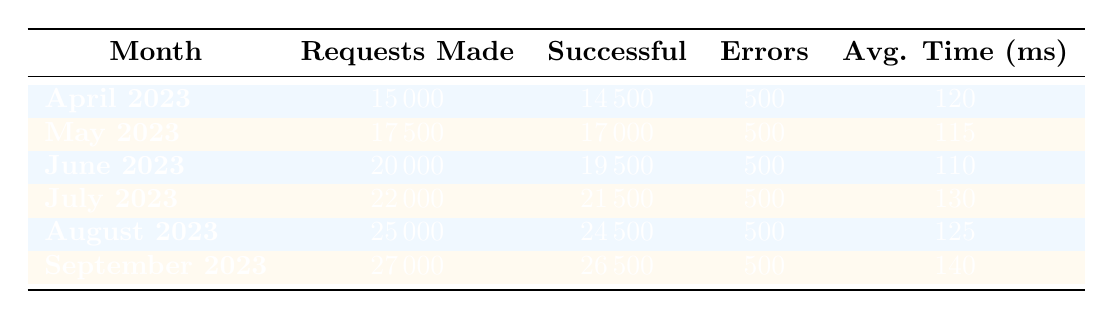What is the average response time in August 2023? The table shows that the average response time for August 2023 is listed directly under the "Avg. Time (ms)" column. It states 125 milliseconds.
Answer: 125 How many total requests were made in June and July 2023? To find the total requests for June and July, we add the "Requests Made" values for these months: 20000 (June) + 22000 (July) = 42000.
Answer: 42000 What is the trend of successful responses from April to September 2023? By examining the "Successful" column in the table, we can see that successful responses increased from 14500 in April to 26500 in September, indicating a consistent upward trend over the months.
Answer: Yes, there is an upward trend Did the number of error responses change from April to September 2023? The "Errors" column for each month consistently shows 500 error responses, meaning the number of error responses did not change over these months.
Answer: No, it did not change What was the month with the highest number of requests made? By checking the "Requests Made" column, September 2023 has the highest value at 27000 requests, which is greater than all previous months.
Answer: September 2023 What is the average number of successful responses across all months? To calculate the average successful responses, we sum all the successful responses: 14500 + 17000 + 19500 + 21500 + 24500 + 26500 = 129500. There are 6 months, so the average is 129500 / 6 = 21583.33, which can be rounded to 21583.
Answer: Approximately 21583 How did the average response time change from April to September 2023? The average response times are 120 ms (April), 115 ms (May), 110 ms (June), 130 ms (July), 125 ms (August), and 140 ms (September). From the data, we see it decreased initially, then increased again by September, showing fluctuation.
Answer: Fluctuated In which month were the responses most successful relative to the total requests made? To find the month with the most successful responses relative to requests, we calculate the success rate for each month (Successful Responses / Requests Made). The calculations yield: April: 96.67%, May: 97.14%, June: 97.50%, July: 97.73%, August: 98.00%, September: 98.15%. The highest rate is in September.
Answer: September 2023 